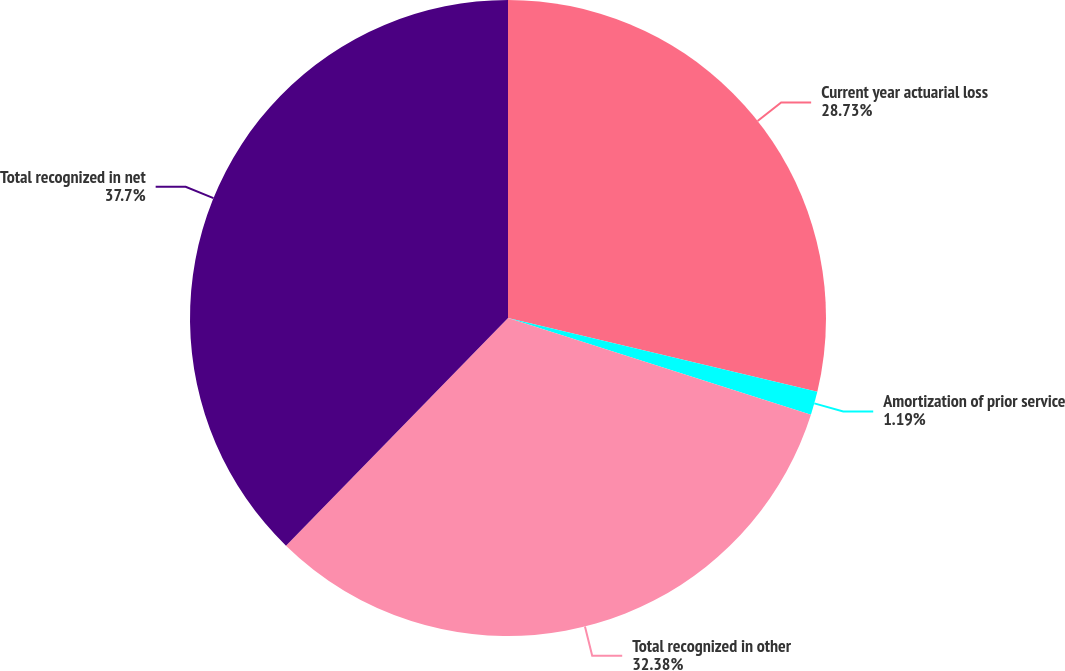Convert chart. <chart><loc_0><loc_0><loc_500><loc_500><pie_chart><fcel>Current year actuarial loss<fcel>Amortization of prior service<fcel>Total recognized in other<fcel>Total recognized in net<nl><fcel>28.73%<fcel>1.19%<fcel>32.38%<fcel>37.7%<nl></chart> 